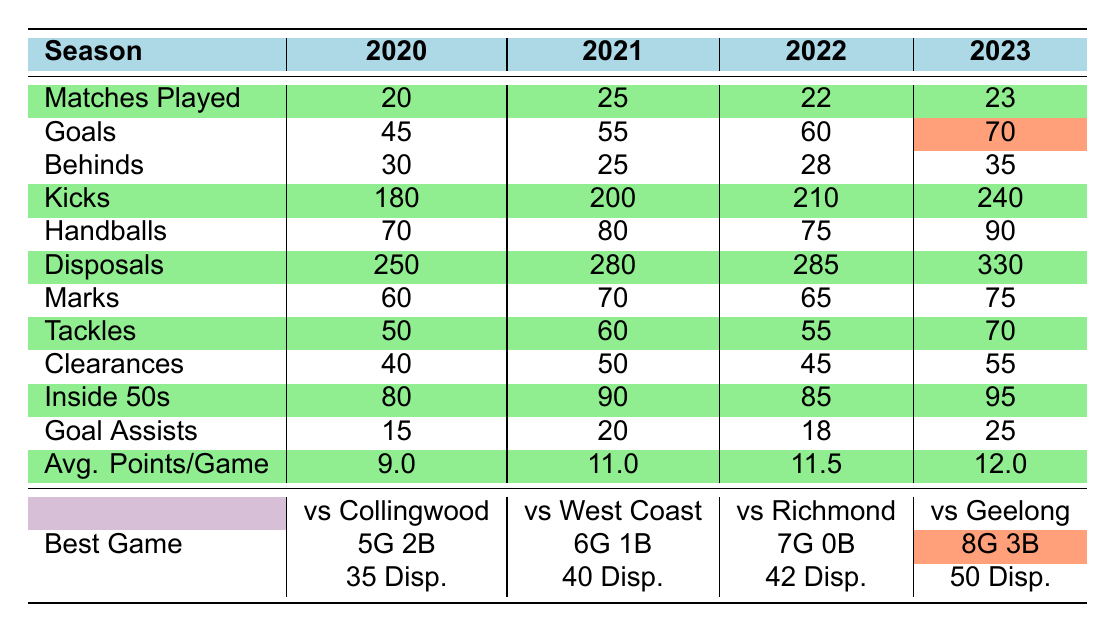What was the highest number of goals scored in a single game during the seasons shown? The highest number of goals scored in a single game is indicated under the "Best Game" row for each season. In 2023, the highest was 8 goals against the Geelong Cats.
Answer: 8 In which season did the team have the highest average points per game? The average points per game are listed in the "Avg. Points/Game" row. The highest value is 12.0 in the 2023 season.
Answer: 2023 What is the total number of goals scored by the Melbourne Demons across all four seasons? To find the total number of goals scored, I will sum the goals for each season: 45 (2020) + 55 (2021) + 60 (2022) + 70 (2023) = 230.
Answer: 230 Which season had the most tackles recorded? The number of tackles is shown in the "Tackles" row. The highest number of tackles is 70 in the 2023 season.
Answer: 2023 Did the Melbourne Demons improve their inside 50s from 2020 to 2023? I will compare inside 50s from the "Inside 50s" row: 80 in 2020 and 95 in 2023. Since 95 is greater than 80, they did improve.
Answer: Yes What is the average number of disposals per game in the 2022 season? The total disposals in the 2022 season is 285, and the number of matches played is 22. To find the average, I divide 285 by 22, which gives approximately 12.95.
Answer: 12.95 How many more goals did the Melbourne Demons score in 2023 than in 2020? I will subtract the goals in 2020 (45) from the goals in 2023 (70): 70 - 45 = 25.
Answer: 25 What was the most goals scored in a game in 2021? The best game for 2021 shows 6 goals scored against the West Coast Eagles.
Answer: 6 Which season had the lowest number of behinds? By reviewing the "Behinds" row, the lowest number is 25 in the 2021 season.
Answer: 2021 What was the total number of matches played across all seasons? To find the total matches played, I will sum the matches played: 20 (2020) + 25 (2021) + 22 (2022) + 23 (2023) = 90.
Answer: 90 Did the Melbourne Demons have an increase in their average points per game from 2020 to 2023? I will check the average points in the "Avg. Points/Game" row: 9.0 in 2020 and 12.0 in 2023 shows an increase.
Answer: Yes 